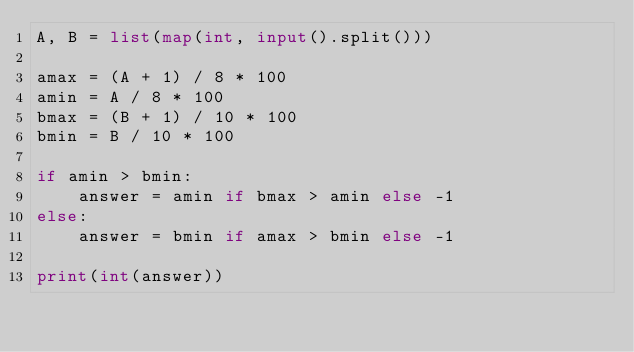Convert code to text. <code><loc_0><loc_0><loc_500><loc_500><_Python_>A, B = list(map(int, input().split()))

amax = (A + 1) / 8 * 100
amin = A / 8 * 100
bmax = (B + 1) / 10 * 100
bmin = B / 10 * 100

if amin > bmin:
    answer = amin if bmax > amin else -1
else:
    answer = bmin if amax > bmin else -1

print(int(answer))
</code> 